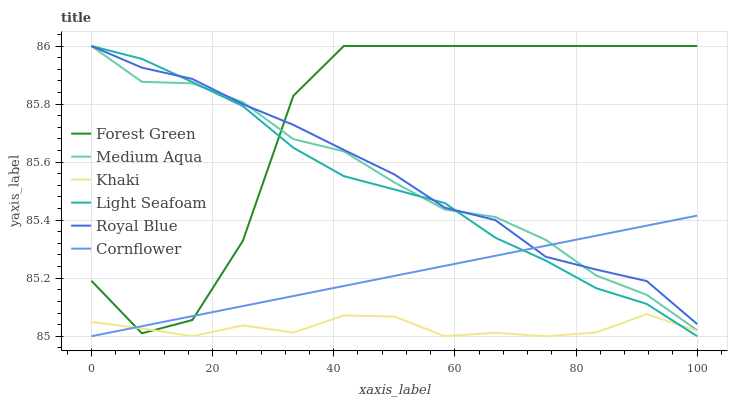Does Khaki have the minimum area under the curve?
Answer yes or no. Yes. Does Forest Green have the maximum area under the curve?
Answer yes or no. Yes. Does Royal Blue have the minimum area under the curve?
Answer yes or no. No. Does Royal Blue have the maximum area under the curve?
Answer yes or no. No. Is Cornflower the smoothest?
Answer yes or no. Yes. Is Forest Green the roughest?
Answer yes or no. Yes. Is Khaki the smoothest?
Answer yes or no. No. Is Khaki the roughest?
Answer yes or no. No. Does Cornflower have the lowest value?
Answer yes or no. Yes. Does Royal Blue have the lowest value?
Answer yes or no. No. Does Light Seafoam have the highest value?
Answer yes or no. Yes. Does Khaki have the highest value?
Answer yes or no. No. Is Khaki less than Medium Aqua?
Answer yes or no. Yes. Is Medium Aqua greater than Khaki?
Answer yes or no. Yes. Does Cornflower intersect Royal Blue?
Answer yes or no. Yes. Is Cornflower less than Royal Blue?
Answer yes or no. No. Is Cornflower greater than Royal Blue?
Answer yes or no. No. Does Khaki intersect Medium Aqua?
Answer yes or no. No. 